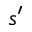<formula> <loc_0><loc_0><loc_500><loc_500>s ^ { \prime }</formula> 